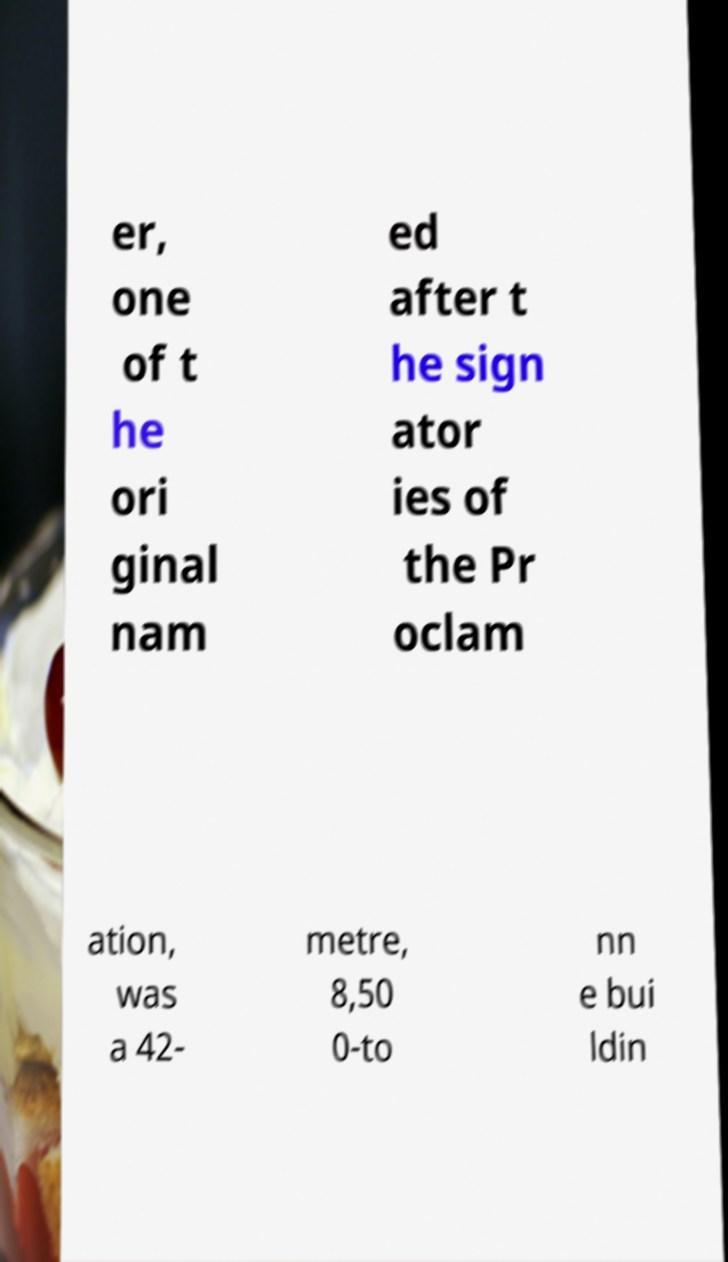Could you extract and type out the text from this image? er, one of t he ori ginal nam ed after t he sign ator ies of the Pr oclam ation, was a 42- metre, 8,50 0-to nn e bui ldin 